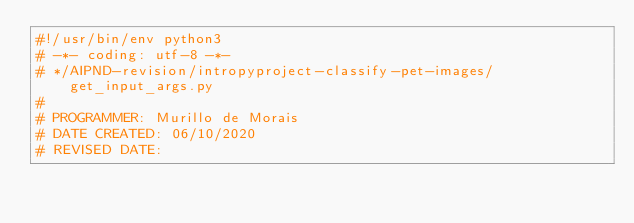Convert code to text. <code><loc_0><loc_0><loc_500><loc_500><_Python_>#!/usr/bin/env python3
# -*- coding: utf-8 -*-
# */AIPND-revision/intropyproject-classify-pet-images/get_input_args.py
#                                                                             
# PROGRAMMER: Murillo de Morais
# DATE CREATED: 06/10/2020              
# REVISED DATE: </code> 